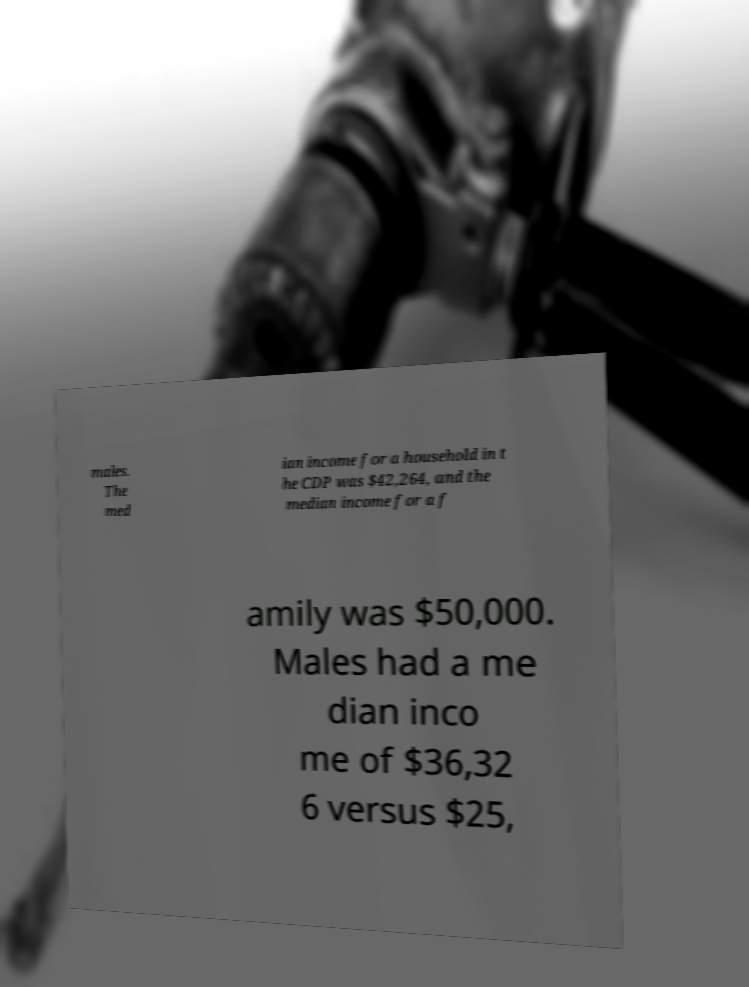What messages or text are displayed in this image? I need them in a readable, typed format. males. The med ian income for a household in t he CDP was $42,264, and the median income for a f amily was $50,000. Males had a me dian inco me of $36,32 6 versus $25, 